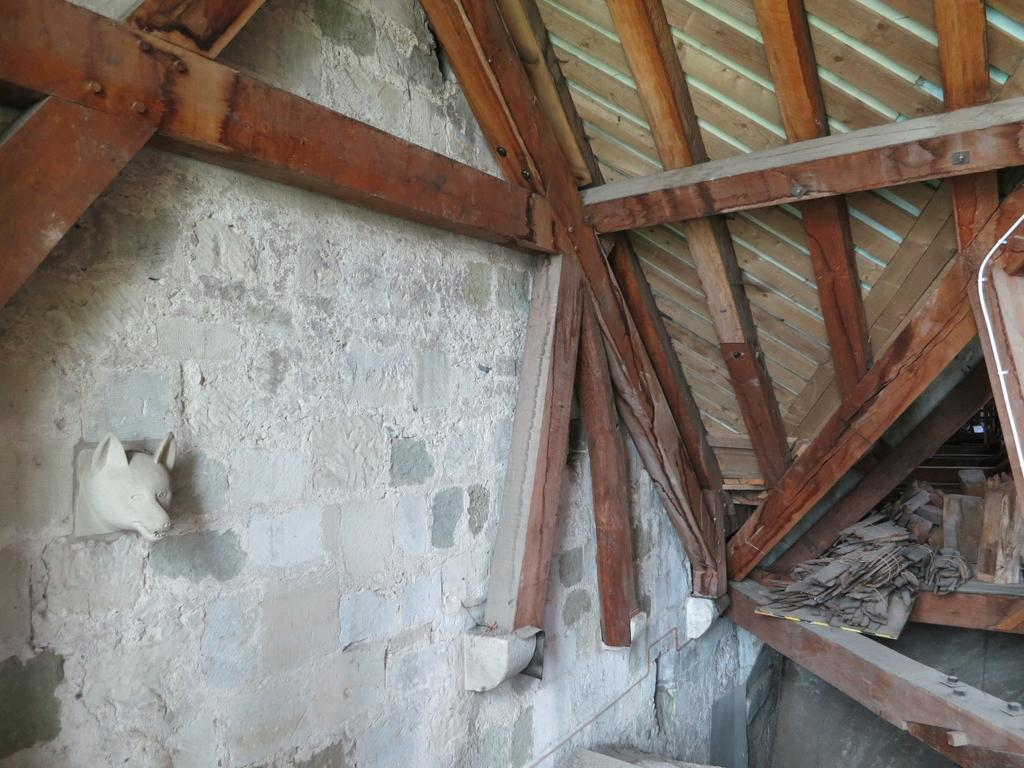What type of location is depicted in the image? The image shows the inside of a house. What can be seen above the interior of the house? There is a roof visible in the image. What type of artwork is present on the wall in the image? There is a sculpture on the wall in the image. What is located at the right side of the image? There are objects present at the right side of the image. How many robins are sitting on the cars outside the house in the image? There are no cars or robins present in the image; it shows the inside of a house. 